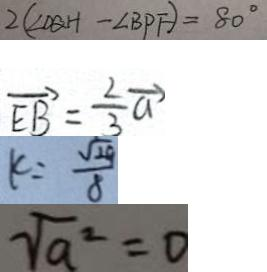Convert formula to latex. <formula><loc_0><loc_0><loc_500><loc_500>2 ( \angle D Q H - \angle B P F ) = 8 0 ^ { \circ } 
 \overrightarrow { E B } = \frac { 2 } { 3 } \overrightarrow { a } 
 k = \frac { \sqrt { 2 9 } } { 8 } 
 \sqrt { a ^ { 2 } } = 0</formula> 